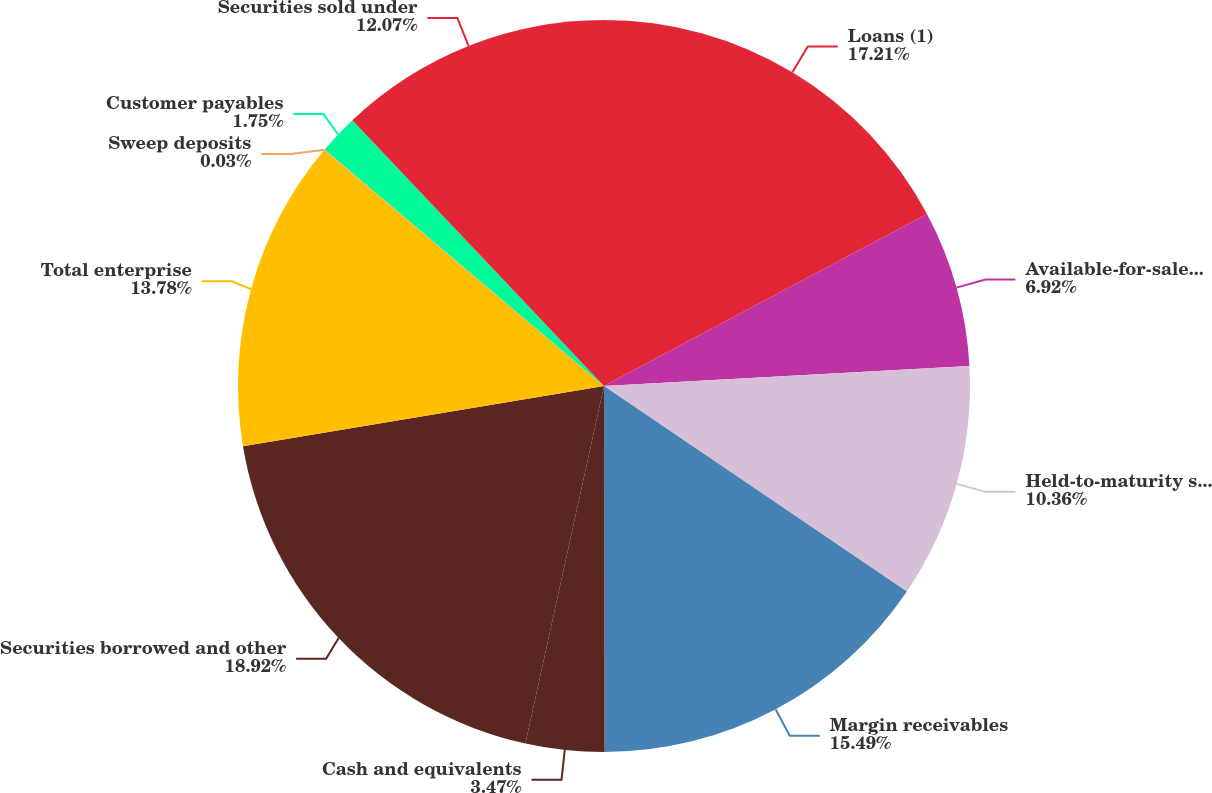Convert chart. <chart><loc_0><loc_0><loc_500><loc_500><pie_chart><fcel>Loans (1)<fcel>Available-for-sale securities<fcel>Held-to-maturity securities<fcel>Margin receivables<fcel>Cash and equivalents<fcel>Securities borrowed and other<fcel>Total enterprise<fcel>Sweep deposits<fcel>Customer payables<fcel>Securities sold under<nl><fcel>17.21%<fcel>6.92%<fcel>10.36%<fcel>15.49%<fcel>3.47%<fcel>18.93%<fcel>13.78%<fcel>0.03%<fcel>1.75%<fcel>12.07%<nl></chart> 